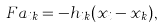<formula> <loc_0><loc_0><loc_500><loc_500>F a _ { i k } = - h _ { i k } ( x _ { i } - x _ { k } ) ,</formula> 